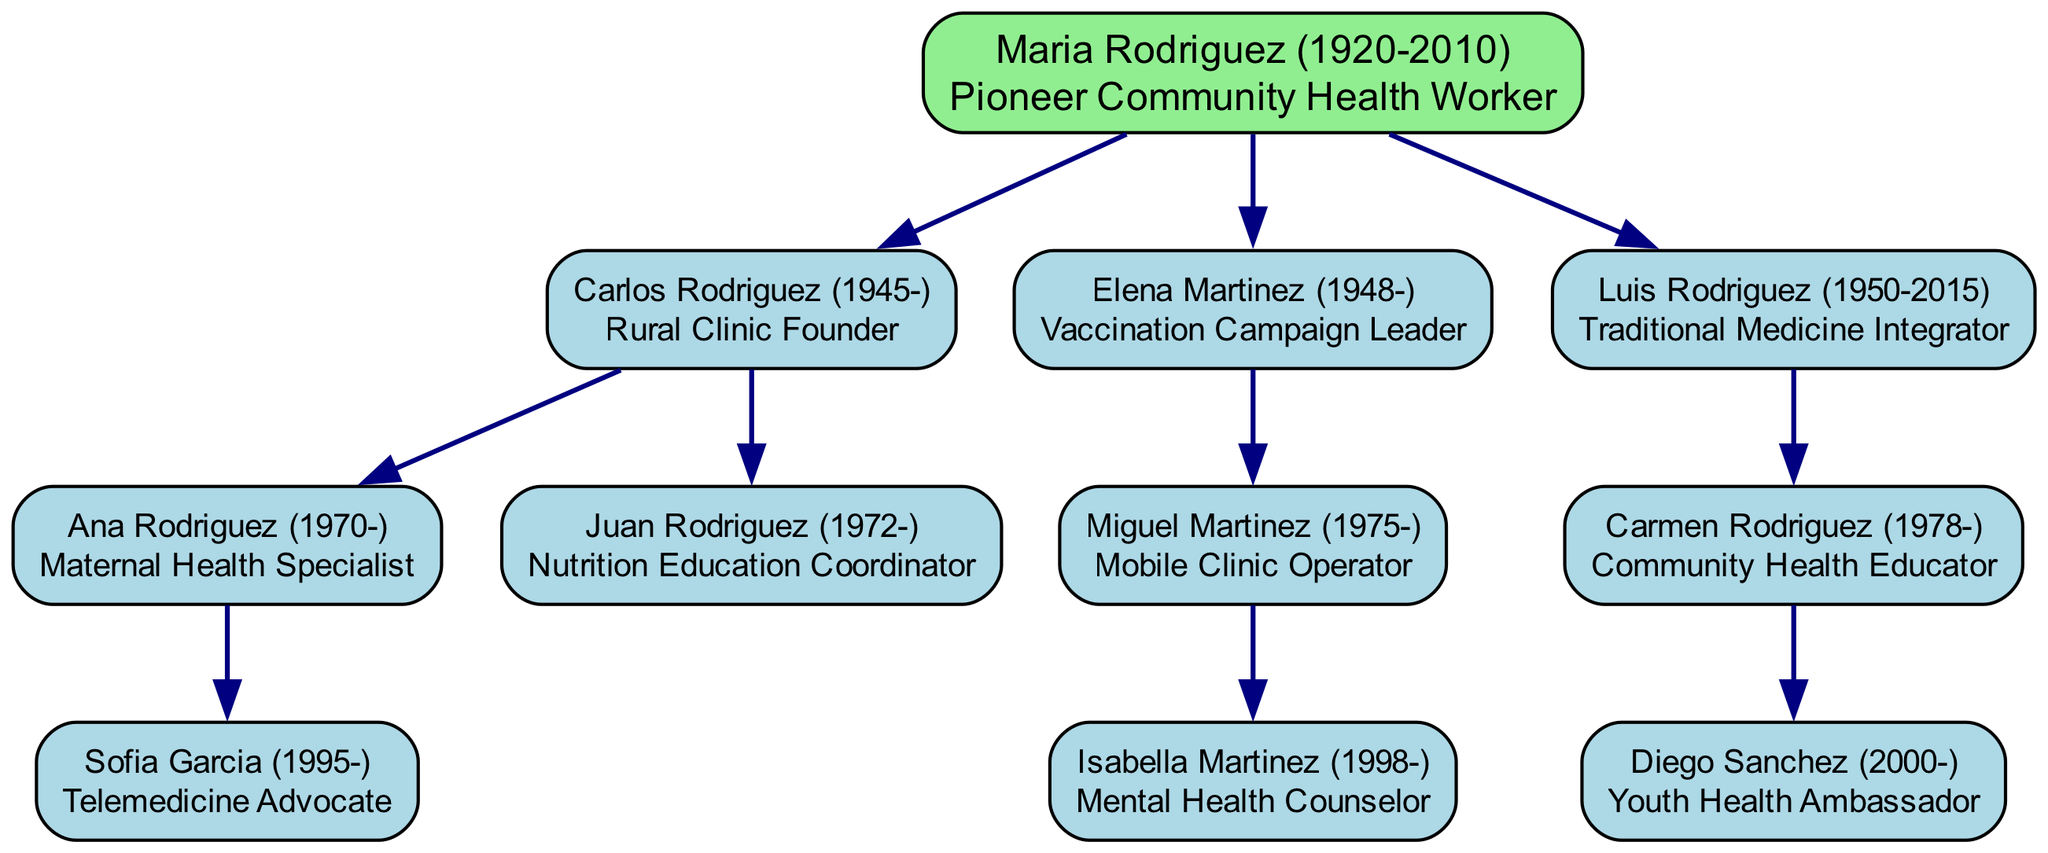What is the name of the root community health worker? The root of the diagram represents the most senior member of the family tree, which is identified as Maria Rodriguez (1920-2010) - Pioneer Community Health Worker.
Answer: Maria Rodriguez (1920-2010) - Pioneer Community Health Worker How many children does Maria Rodriguez have? By examining the connections stemming from Maria Rodriguez, we can count the branches: Carlos Rodriguez, Elena Martinez, and Luis Rodriguez, totaling three children.
Answer: 3 Who is the Maternal Health Specialist? Tracing the descendants starting from Maria Rodriguez, we find that Ana Rodriguez (1970-) is specifically mentioned as the Maternal Health Specialist.
Answer: Ana Rodriguez (1970-) - Maternal Health Specialist Which family member operates a mobile clinic? From the path leading to Miguel Martinez (1975-), the diagram indicates that he is marked as the Mobile Clinic Operator, thus identifying him with operating a mobile clinic.
Answer: Miguel Martinez (1975-) - Mobile Clinic Operator What year did Luis Rodriguez pass away? By looking at the details directly associated with Luis Rodriguez, it is noted that he passed away in 2015.
Answer: 2015 How is Sofia Garcia related to Carlos Rodriguez? To find the relationship, we see that Sofia Garcia is the child of Ana Rodriguez, who in turn is the daughter of Carlos Rodriguez, leading to the conclusion that Sofia Garcia is Carlos Rodriguez's granddaughter.
Answer: Granddaughter Which health worker focuses on youth health advocacy? Checking the descendants of Carmen Rodriguez, we find that Diego Sanchez (2000-) is listed as the Youth Health Ambassador, indicating his focus on youth health advocacy.
Answer: Diego Sanchez (2000-) - Youth Health Ambassador What is the profession of Isabella Martinez? The diagram specifically labels Isabella Martinez as the Mental Health Counselor, clarifying her professional role in the healthcare advocacy community.
Answer: Mental Health Counselor How many generations are represented in this family tree? Starting from Maria Rodriguez as the root, we count the successive generations represented in the diagram as follows: Maria Rodriguez (1st), her children (2nd), and then her grandchildren (3rd), totaling three generations in the diagram.
Answer: 3 